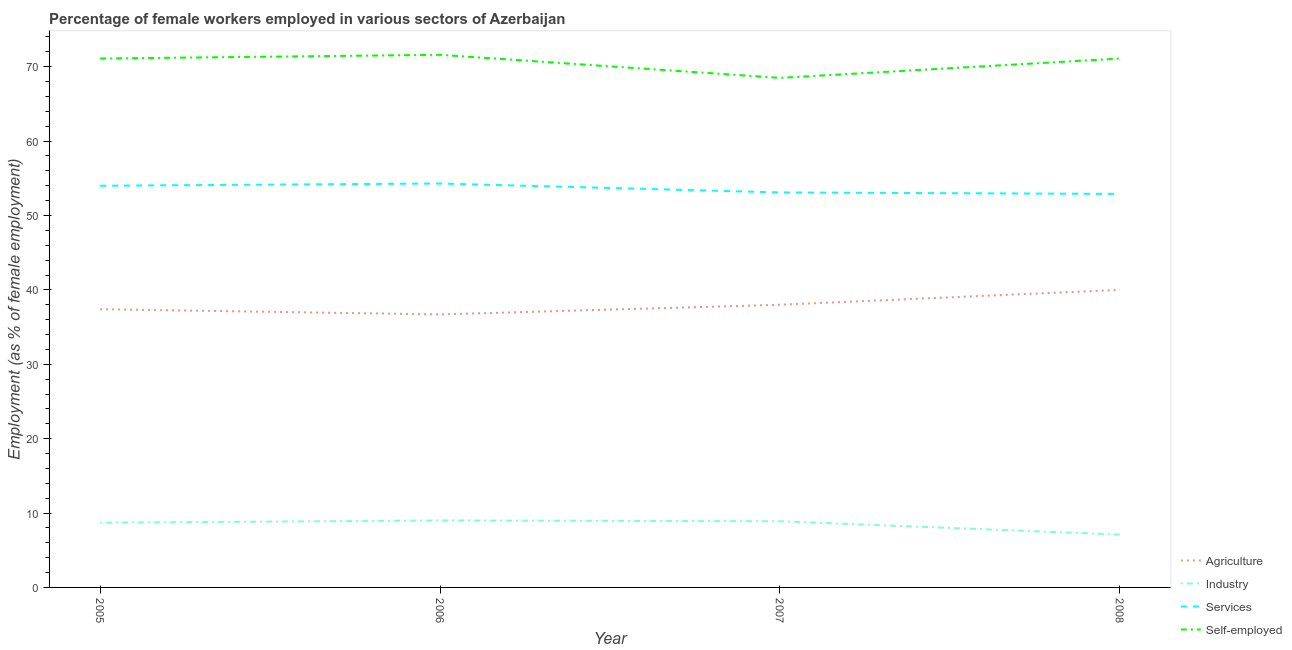Does the line corresponding to percentage of female workers in industry intersect with the line corresponding to percentage of female workers in services?
Your response must be concise. No. Is the number of lines equal to the number of legend labels?
Your answer should be compact. Yes. What is the percentage of self employed female workers in 2006?
Your response must be concise. 71.6. Across all years, what is the maximum percentage of female workers in services?
Give a very brief answer. 54.3. Across all years, what is the minimum percentage of female workers in agriculture?
Your answer should be very brief. 36.7. What is the total percentage of female workers in services in the graph?
Give a very brief answer. 214.3. What is the difference between the percentage of female workers in services in 2006 and that in 2007?
Ensure brevity in your answer.  1.2. What is the difference between the percentage of self employed female workers in 2006 and the percentage of female workers in agriculture in 2008?
Provide a succinct answer. 31.6. What is the average percentage of female workers in services per year?
Ensure brevity in your answer.  53.57. In the year 2008, what is the difference between the percentage of female workers in industry and percentage of female workers in agriculture?
Make the answer very short. -32.9. What is the ratio of the percentage of female workers in services in 2005 to that in 2008?
Keep it short and to the point. 1.02. Is the percentage of female workers in services in 2005 less than that in 2008?
Keep it short and to the point. No. What is the difference between the highest and the second highest percentage of female workers in industry?
Give a very brief answer. 0.1. What is the difference between the highest and the lowest percentage of female workers in agriculture?
Keep it short and to the point. 3.3. In how many years, is the percentage of female workers in agriculture greater than the average percentage of female workers in agriculture taken over all years?
Your answer should be compact. 1. Is the percentage of self employed female workers strictly less than the percentage of female workers in industry over the years?
Give a very brief answer. No. How many lines are there?
Your answer should be very brief. 4. How many years are there in the graph?
Keep it short and to the point. 4. What is the difference between two consecutive major ticks on the Y-axis?
Make the answer very short. 10. Are the values on the major ticks of Y-axis written in scientific E-notation?
Provide a succinct answer. No. Does the graph contain any zero values?
Offer a terse response. No. Does the graph contain grids?
Make the answer very short. No. Where does the legend appear in the graph?
Your response must be concise. Bottom right. How many legend labels are there?
Provide a succinct answer. 4. How are the legend labels stacked?
Give a very brief answer. Vertical. What is the title of the graph?
Give a very brief answer. Percentage of female workers employed in various sectors of Azerbaijan. What is the label or title of the X-axis?
Your response must be concise. Year. What is the label or title of the Y-axis?
Your response must be concise. Employment (as % of female employment). What is the Employment (as % of female employment) of Agriculture in 2005?
Your response must be concise. 37.4. What is the Employment (as % of female employment) in Industry in 2005?
Give a very brief answer. 8.7. What is the Employment (as % of female employment) in Self-employed in 2005?
Give a very brief answer. 71.1. What is the Employment (as % of female employment) of Agriculture in 2006?
Offer a terse response. 36.7. What is the Employment (as % of female employment) of Services in 2006?
Your answer should be very brief. 54.3. What is the Employment (as % of female employment) in Self-employed in 2006?
Ensure brevity in your answer.  71.6. What is the Employment (as % of female employment) of Agriculture in 2007?
Your answer should be compact. 38. What is the Employment (as % of female employment) of Industry in 2007?
Provide a short and direct response. 8.9. What is the Employment (as % of female employment) in Services in 2007?
Provide a short and direct response. 53.1. What is the Employment (as % of female employment) in Self-employed in 2007?
Ensure brevity in your answer.  68.5. What is the Employment (as % of female employment) of Agriculture in 2008?
Your response must be concise. 40. What is the Employment (as % of female employment) in Industry in 2008?
Provide a short and direct response. 7.1. What is the Employment (as % of female employment) of Services in 2008?
Provide a succinct answer. 52.9. What is the Employment (as % of female employment) of Self-employed in 2008?
Offer a terse response. 71.1. Across all years, what is the maximum Employment (as % of female employment) in Services?
Keep it short and to the point. 54.3. Across all years, what is the maximum Employment (as % of female employment) in Self-employed?
Make the answer very short. 71.6. Across all years, what is the minimum Employment (as % of female employment) in Agriculture?
Provide a short and direct response. 36.7. Across all years, what is the minimum Employment (as % of female employment) in Industry?
Make the answer very short. 7.1. Across all years, what is the minimum Employment (as % of female employment) of Services?
Keep it short and to the point. 52.9. Across all years, what is the minimum Employment (as % of female employment) in Self-employed?
Offer a very short reply. 68.5. What is the total Employment (as % of female employment) in Agriculture in the graph?
Keep it short and to the point. 152.1. What is the total Employment (as % of female employment) of Industry in the graph?
Offer a very short reply. 33.7. What is the total Employment (as % of female employment) in Services in the graph?
Keep it short and to the point. 214.3. What is the total Employment (as % of female employment) of Self-employed in the graph?
Offer a very short reply. 282.3. What is the difference between the Employment (as % of female employment) in Agriculture in 2005 and that in 2006?
Provide a short and direct response. 0.7. What is the difference between the Employment (as % of female employment) in Industry in 2005 and that in 2006?
Offer a very short reply. -0.3. What is the difference between the Employment (as % of female employment) of Services in 2005 and that in 2006?
Your answer should be very brief. -0.3. What is the difference between the Employment (as % of female employment) of Self-employed in 2005 and that in 2006?
Keep it short and to the point. -0.5. What is the difference between the Employment (as % of female employment) of Agriculture in 2005 and that in 2007?
Your answer should be very brief. -0.6. What is the difference between the Employment (as % of female employment) of Services in 2005 and that in 2007?
Keep it short and to the point. 0.9. What is the difference between the Employment (as % of female employment) in Self-employed in 2005 and that in 2007?
Ensure brevity in your answer.  2.6. What is the difference between the Employment (as % of female employment) of Industry in 2005 and that in 2008?
Give a very brief answer. 1.6. What is the difference between the Employment (as % of female employment) of Services in 2005 and that in 2008?
Offer a very short reply. 1.1. What is the difference between the Employment (as % of female employment) of Agriculture in 2006 and that in 2007?
Offer a very short reply. -1.3. What is the difference between the Employment (as % of female employment) of Industry in 2006 and that in 2007?
Provide a succinct answer. 0.1. What is the difference between the Employment (as % of female employment) of Self-employed in 2006 and that in 2007?
Offer a terse response. 3.1. What is the difference between the Employment (as % of female employment) in Industry in 2006 and that in 2008?
Provide a succinct answer. 1.9. What is the difference between the Employment (as % of female employment) in Self-employed in 2007 and that in 2008?
Keep it short and to the point. -2.6. What is the difference between the Employment (as % of female employment) of Agriculture in 2005 and the Employment (as % of female employment) of Industry in 2006?
Offer a very short reply. 28.4. What is the difference between the Employment (as % of female employment) of Agriculture in 2005 and the Employment (as % of female employment) of Services in 2006?
Provide a short and direct response. -16.9. What is the difference between the Employment (as % of female employment) in Agriculture in 2005 and the Employment (as % of female employment) in Self-employed in 2006?
Keep it short and to the point. -34.2. What is the difference between the Employment (as % of female employment) in Industry in 2005 and the Employment (as % of female employment) in Services in 2006?
Provide a short and direct response. -45.6. What is the difference between the Employment (as % of female employment) in Industry in 2005 and the Employment (as % of female employment) in Self-employed in 2006?
Keep it short and to the point. -62.9. What is the difference between the Employment (as % of female employment) in Services in 2005 and the Employment (as % of female employment) in Self-employed in 2006?
Your answer should be compact. -17.6. What is the difference between the Employment (as % of female employment) of Agriculture in 2005 and the Employment (as % of female employment) of Industry in 2007?
Make the answer very short. 28.5. What is the difference between the Employment (as % of female employment) of Agriculture in 2005 and the Employment (as % of female employment) of Services in 2007?
Your response must be concise. -15.7. What is the difference between the Employment (as % of female employment) in Agriculture in 2005 and the Employment (as % of female employment) in Self-employed in 2007?
Give a very brief answer. -31.1. What is the difference between the Employment (as % of female employment) of Industry in 2005 and the Employment (as % of female employment) of Services in 2007?
Ensure brevity in your answer.  -44.4. What is the difference between the Employment (as % of female employment) of Industry in 2005 and the Employment (as % of female employment) of Self-employed in 2007?
Provide a succinct answer. -59.8. What is the difference between the Employment (as % of female employment) in Services in 2005 and the Employment (as % of female employment) in Self-employed in 2007?
Make the answer very short. -14.5. What is the difference between the Employment (as % of female employment) of Agriculture in 2005 and the Employment (as % of female employment) of Industry in 2008?
Offer a terse response. 30.3. What is the difference between the Employment (as % of female employment) in Agriculture in 2005 and the Employment (as % of female employment) in Services in 2008?
Your answer should be compact. -15.5. What is the difference between the Employment (as % of female employment) in Agriculture in 2005 and the Employment (as % of female employment) in Self-employed in 2008?
Provide a short and direct response. -33.7. What is the difference between the Employment (as % of female employment) in Industry in 2005 and the Employment (as % of female employment) in Services in 2008?
Offer a terse response. -44.2. What is the difference between the Employment (as % of female employment) of Industry in 2005 and the Employment (as % of female employment) of Self-employed in 2008?
Provide a succinct answer. -62.4. What is the difference between the Employment (as % of female employment) in Services in 2005 and the Employment (as % of female employment) in Self-employed in 2008?
Make the answer very short. -17.1. What is the difference between the Employment (as % of female employment) of Agriculture in 2006 and the Employment (as % of female employment) of Industry in 2007?
Give a very brief answer. 27.8. What is the difference between the Employment (as % of female employment) in Agriculture in 2006 and the Employment (as % of female employment) in Services in 2007?
Your answer should be very brief. -16.4. What is the difference between the Employment (as % of female employment) of Agriculture in 2006 and the Employment (as % of female employment) of Self-employed in 2007?
Your response must be concise. -31.8. What is the difference between the Employment (as % of female employment) in Industry in 2006 and the Employment (as % of female employment) in Services in 2007?
Make the answer very short. -44.1. What is the difference between the Employment (as % of female employment) in Industry in 2006 and the Employment (as % of female employment) in Self-employed in 2007?
Make the answer very short. -59.5. What is the difference between the Employment (as % of female employment) of Agriculture in 2006 and the Employment (as % of female employment) of Industry in 2008?
Provide a short and direct response. 29.6. What is the difference between the Employment (as % of female employment) of Agriculture in 2006 and the Employment (as % of female employment) of Services in 2008?
Provide a short and direct response. -16.2. What is the difference between the Employment (as % of female employment) in Agriculture in 2006 and the Employment (as % of female employment) in Self-employed in 2008?
Provide a short and direct response. -34.4. What is the difference between the Employment (as % of female employment) of Industry in 2006 and the Employment (as % of female employment) of Services in 2008?
Give a very brief answer. -43.9. What is the difference between the Employment (as % of female employment) of Industry in 2006 and the Employment (as % of female employment) of Self-employed in 2008?
Offer a very short reply. -62.1. What is the difference between the Employment (as % of female employment) of Services in 2006 and the Employment (as % of female employment) of Self-employed in 2008?
Offer a very short reply. -16.8. What is the difference between the Employment (as % of female employment) of Agriculture in 2007 and the Employment (as % of female employment) of Industry in 2008?
Offer a terse response. 30.9. What is the difference between the Employment (as % of female employment) of Agriculture in 2007 and the Employment (as % of female employment) of Services in 2008?
Give a very brief answer. -14.9. What is the difference between the Employment (as % of female employment) in Agriculture in 2007 and the Employment (as % of female employment) in Self-employed in 2008?
Offer a very short reply. -33.1. What is the difference between the Employment (as % of female employment) of Industry in 2007 and the Employment (as % of female employment) of Services in 2008?
Offer a terse response. -44. What is the difference between the Employment (as % of female employment) in Industry in 2007 and the Employment (as % of female employment) in Self-employed in 2008?
Ensure brevity in your answer.  -62.2. What is the difference between the Employment (as % of female employment) of Services in 2007 and the Employment (as % of female employment) of Self-employed in 2008?
Provide a succinct answer. -18. What is the average Employment (as % of female employment) in Agriculture per year?
Ensure brevity in your answer.  38.02. What is the average Employment (as % of female employment) of Industry per year?
Ensure brevity in your answer.  8.43. What is the average Employment (as % of female employment) of Services per year?
Your response must be concise. 53.58. What is the average Employment (as % of female employment) in Self-employed per year?
Your response must be concise. 70.58. In the year 2005, what is the difference between the Employment (as % of female employment) in Agriculture and Employment (as % of female employment) in Industry?
Ensure brevity in your answer.  28.7. In the year 2005, what is the difference between the Employment (as % of female employment) in Agriculture and Employment (as % of female employment) in Services?
Your answer should be very brief. -16.6. In the year 2005, what is the difference between the Employment (as % of female employment) of Agriculture and Employment (as % of female employment) of Self-employed?
Keep it short and to the point. -33.7. In the year 2005, what is the difference between the Employment (as % of female employment) of Industry and Employment (as % of female employment) of Services?
Offer a very short reply. -45.3. In the year 2005, what is the difference between the Employment (as % of female employment) of Industry and Employment (as % of female employment) of Self-employed?
Provide a short and direct response. -62.4. In the year 2005, what is the difference between the Employment (as % of female employment) in Services and Employment (as % of female employment) in Self-employed?
Ensure brevity in your answer.  -17.1. In the year 2006, what is the difference between the Employment (as % of female employment) of Agriculture and Employment (as % of female employment) of Industry?
Offer a very short reply. 27.7. In the year 2006, what is the difference between the Employment (as % of female employment) of Agriculture and Employment (as % of female employment) of Services?
Ensure brevity in your answer.  -17.6. In the year 2006, what is the difference between the Employment (as % of female employment) of Agriculture and Employment (as % of female employment) of Self-employed?
Provide a succinct answer. -34.9. In the year 2006, what is the difference between the Employment (as % of female employment) in Industry and Employment (as % of female employment) in Services?
Make the answer very short. -45.3. In the year 2006, what is the difference between the Employment (as % of female employment) in Industry and Employment (as % of female employment) in Self-employed?
Your answer should be compact. -62.6. In the year 2006, what is the difference between the Employment (as % of female employment) in Services and Employment (as % of female employment) in Self-employed?
Make the answer very short. -17.3. In the year 2007, what is the difference between the Employment (as % of female employment) in Agriculture and Employment (as % of female employment) in Industry?
Provide a succinct answer. 29.1. In the year 2007, what is the difference between the Employment (as % of female employment) in Agriculture and Employment (as % of female employment) in Services?
Provide a succinct answer. -15.1. In the year 2007, what is the difference between the Employment (as % of female employment) of Agriculture and Employment (as % of female employment) of Self-employed?
Provide a short and direct response. -30.5. In the year 2007, what is the difference between the Employment (as % of female employment) of Industry and Employment (as % of female employment) of Services?
Offer a terse response. -44.2. In the year 2007, what is the difference between the Employment (as % of female employment) in Industry and Employment (as % of female employment) in Self-employed?
Your answer should be compact. -59.6. In the year 2007, what is the difference between the Employment (as % of female employment) in Services and Employment (as % of female employment) in Self-employed?
Make the answer very short. -15.4. In the year 2008, what is the difference between the Employment (as % of female employment) of Agriculture and Employment (as % of female employment) of Industry?
Give a very brief answer. 32.9. In the year 2008, what is the difference between the Employment (as % of female employment) of Agriculture and Employment (as % of female employment) of Services?
Give a very brief answer. -12.9. In the year 2008, what is the difference between the Employment (as % of female employment) in Agriculture and Employment (as % of female employment) in Self-employed?
Give a very brief answer. -31.1. In the year 2008, what is the difference between the Employment (as % of female employment) of Industry and Employment (as % of female employment) of Services?
Keep it short and to the point. -45.8. In the year 2008, what is the difference between the Employment (as % of female employment) in Industry and Employment (as % of female employment) in Self-employed?
Provide a succinct answer. -64. In the year 2008, what is the difference between the Employment (as % of female employment) in Services and Employment (as % of female employment) in Self-employed?
Give a very brief answer. -18.2. What is the ratio of the Employment (as % of female employment) in Agriculture in 2005 to that in 2006?
Your answer should be very brief. 1.02. What is the ratio of the Employment (as % of female employment) of Industry in 2005 to that in 2006?
Provide a short and direct response. 0.97. What is the ratio of the Employment (as % of female employment) of Self-employed in 2005 to that in 2006?
Offer a terse response. 0.99. What is the ratio of the Employment (as % of female employment) in Agriculture in 2005 to that in 2007?
Keep it short and to the point. 0.98. What is the ratio of the Employment (as % of female employment) in Industry in 2005 to that in 2007?
Ensure brevity in your answer.  0.98. What is the ratio of the Employment (as % of female employment) in Services in 2005 to that in 2007?
Your answer should be compact. 1.02. What is the ratio of the Employment (as % of female employment) of Self-employed in 2005 to that in 2007?
Keep it short and to the point. 1.04. What is the ratio of the Employment (as % of female employment) in Agriculture in 2005 to that in 2008?
Provide a short and direct response. 0.94. What is the ratio of the Employment (as % of female employment) in Industry in 2005 to that in 2008?
Offer a terse response. 1.23. What is the ratio of the Employment (as % of female employment) in Services in 2005 to that in 2008?
Ensure brevity in your answer.  1.02. What is the ratio of the Employment (as % of female employment) of Agriculture in 2006 to that in 2007?
Offer a terse response. 0.97. What is the ratio of the Employment (as % of female employment) in Industry in 2006 to that in 2007?
Provide a succinct answer. 1.01. What is the ratio of the Employment (as % of female employment) in Services in 2006 to that in 2007?
Your response must be concise. 1.02. What is the ratio of the Employment (as % of female employment) of Self-employed in 2006 to that in 2007?
Provide a short and direct response. 1.05. What is the ratio of the Employment (as % of female employment) of Agriculture in 2006 to that in 2008?
Your answer should be compact. 0.92. What is the ratio of the Employment (as % of female employment) of Industry in 2006 to that in 2008?
Your response must be concise. 1.27. What is the ratio of the Employment (as % of female employment) in Services in 2006 to that in 2008?
Your answer should be compact. 1.03. What is the ratio of the Employment (as % of female employment) in Industry in 2007 to that in 2008?
Make the answer very short. 1.25. What is the ratio of the Employment (as % of female employment) in Services in 2007 to that in 2008?
Provide a succinct answer. 1. What is the ratio of the Employment (as % of female employment) of Self-employed in 2007 to that in 2008?
Provide a short and direct response. 0.96. 